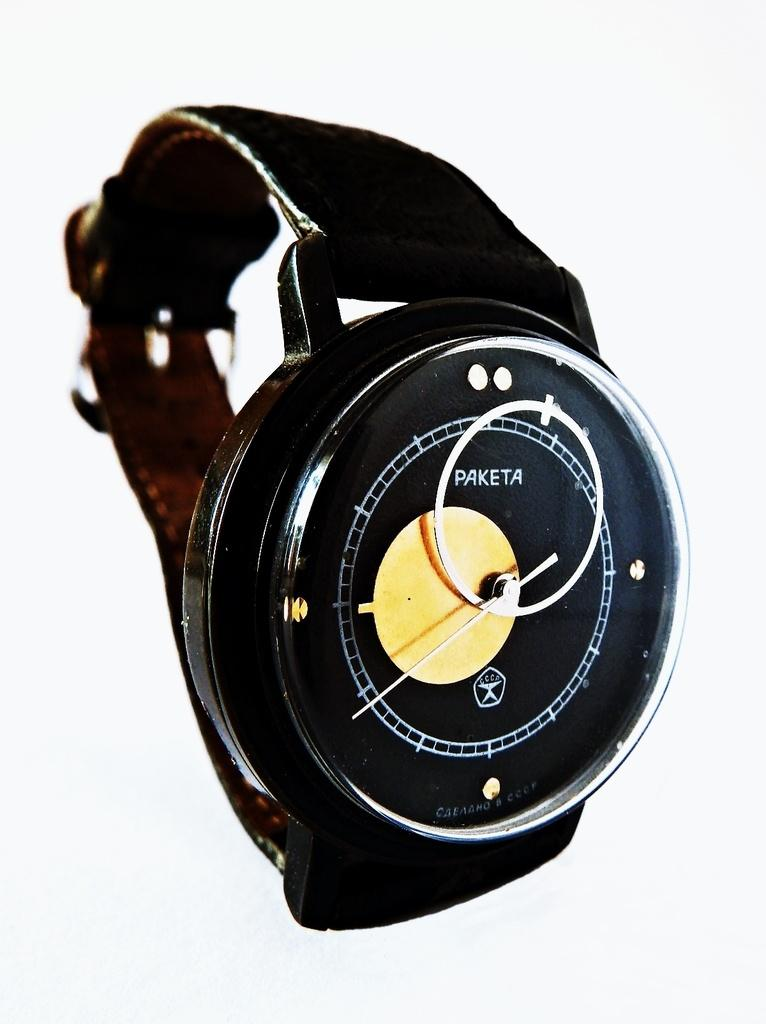<image>
Relay a brief, clear account of the picture shown. Paketa watch with a black band sits on a white surface. 